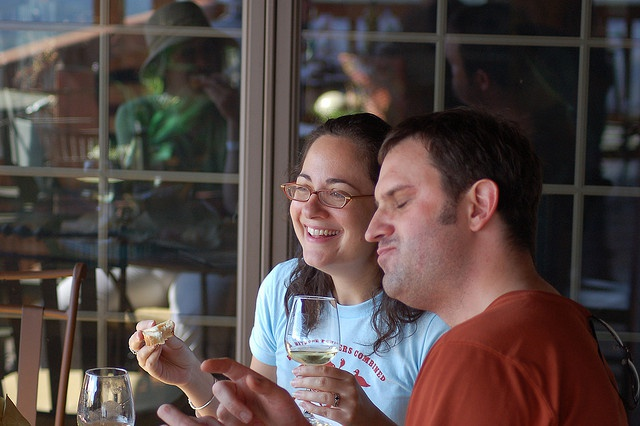Describe the objects in this image and their specific colors. I can see people in gray, maroon, black, brown, and darkgray tones, people in gray, brown, lightblue, and maroon tones, people in gray, black, darkgreen, and teal tones, people in gray and black tones, and chair in gray, black, and maroon tones in this image. 